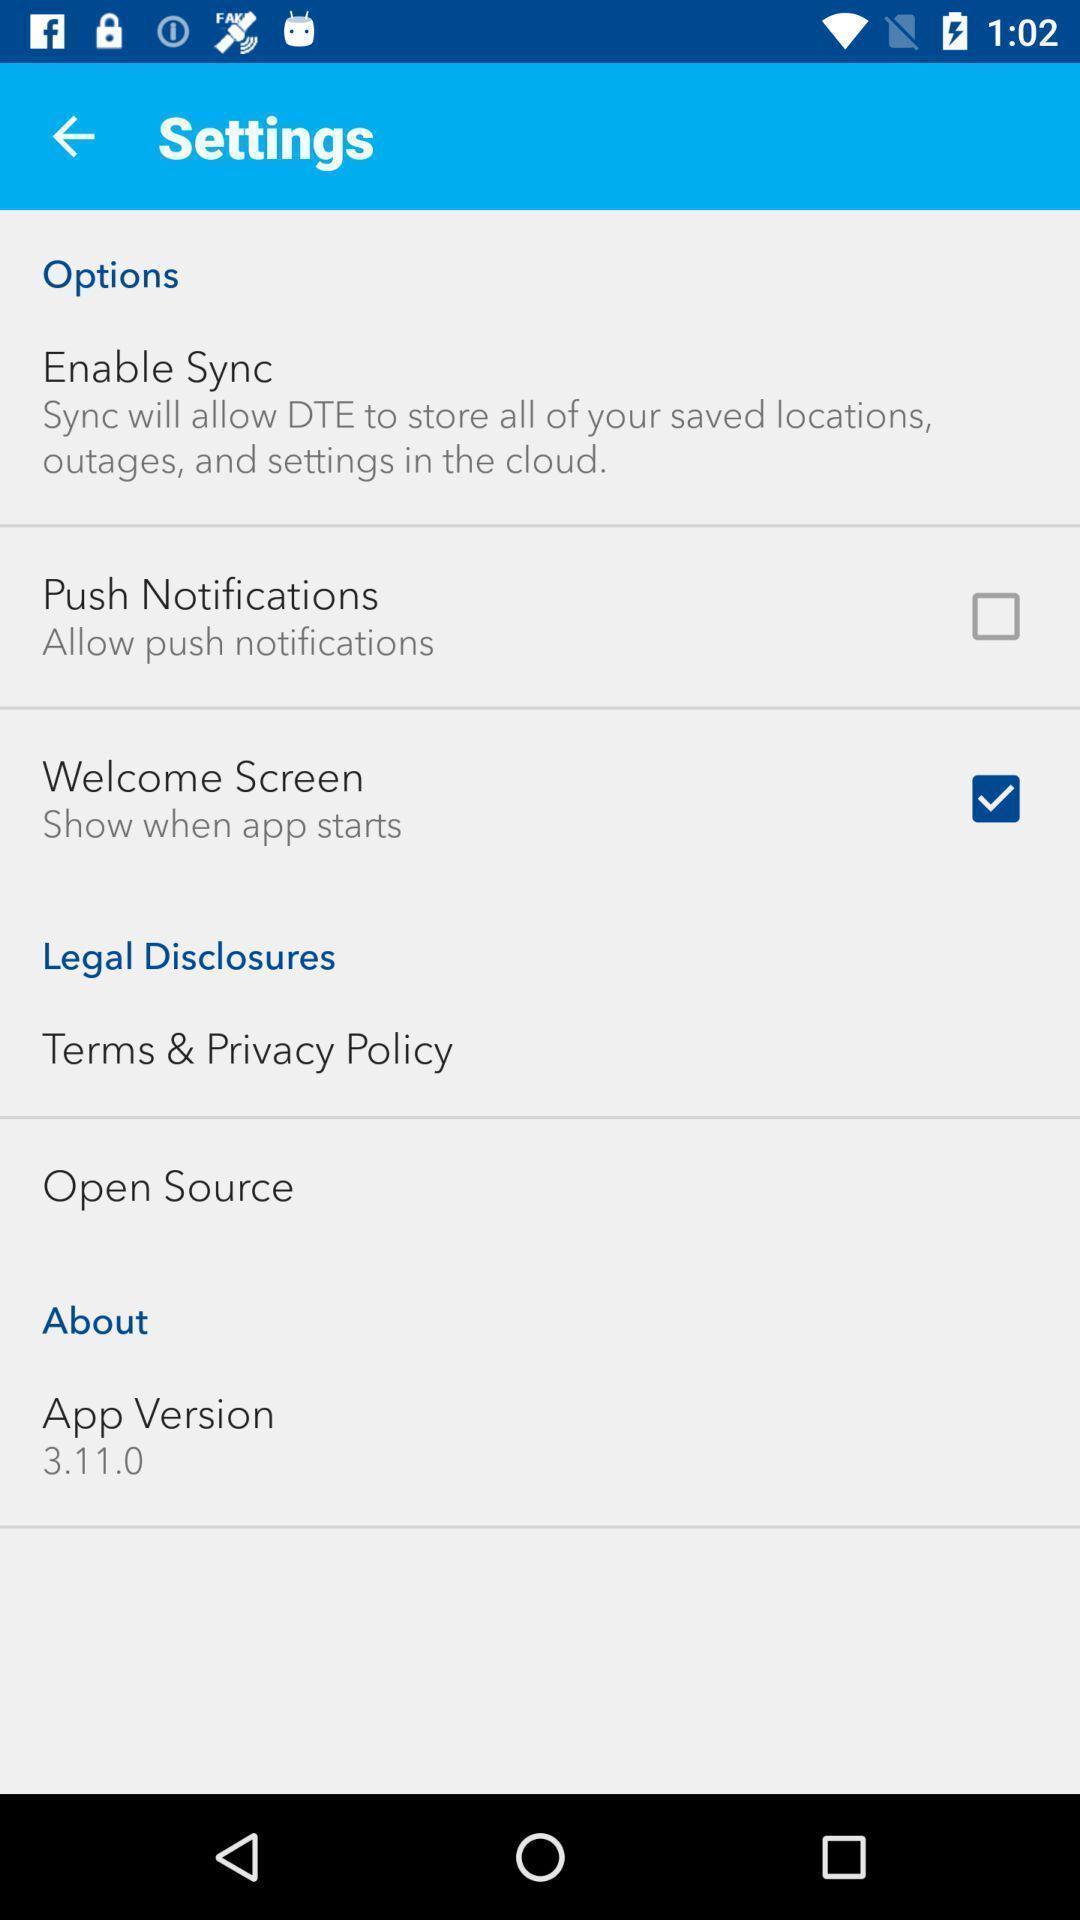Give me a narrative description of this picture. Page displays various settings in app. 